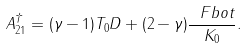Convert formula to latex. <formula><loc_0><loc_0><loc_500><loc_500>A ^ { \dag } _ { 2 1 } = ( \gamma - 1 ) T _ { 0 } D + ( 2 - \gamma ) \frac { \ F b o t } { K _ { 0 } } .</formula> 